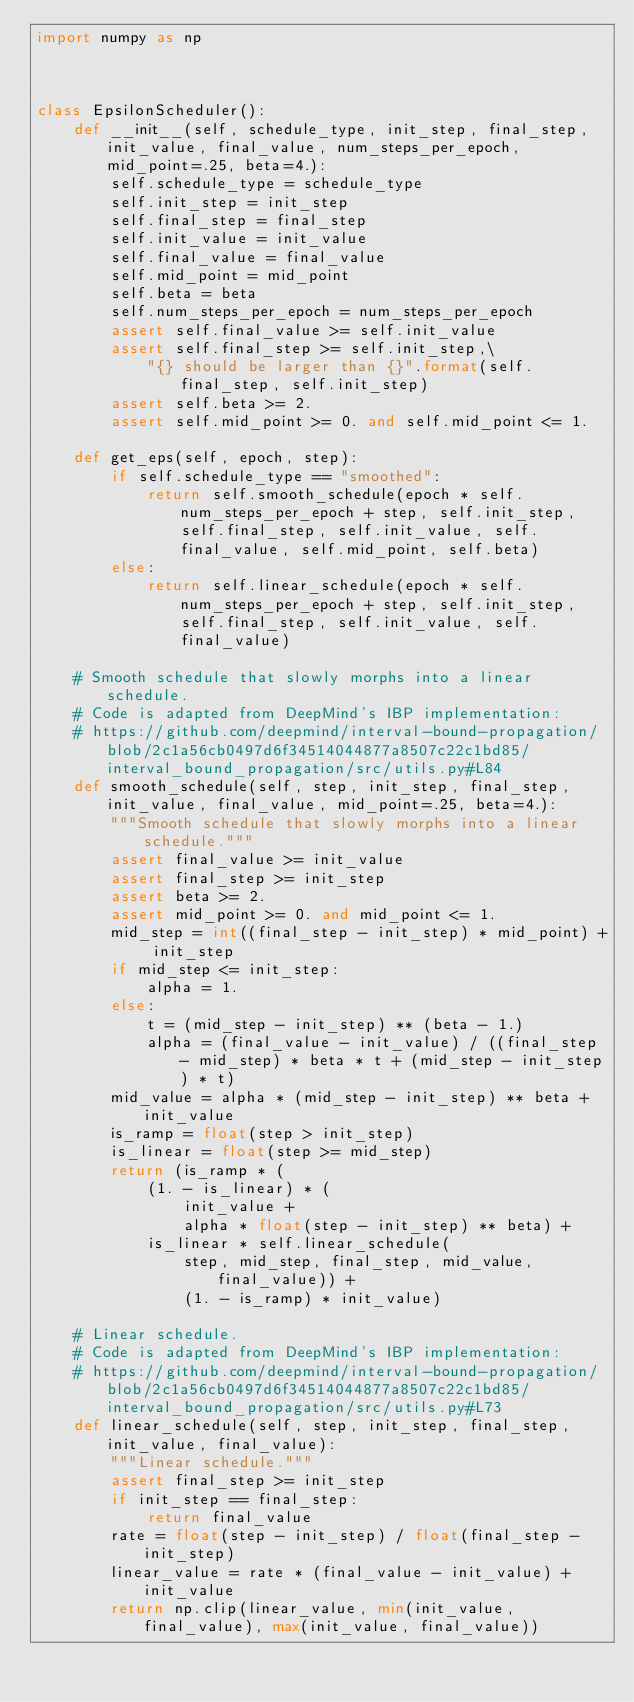<code> <loc_0><loc_0><loc_500><loc_500><_Python_>import numpy as np

 

class EpsilonScheduler():
    def __init__(self, schedule_type, init_step, final_step, init_value, final_value, num_steps_per_epoch, mid_point=.25, beta=4.):
        self.schedule_type = schedule_type
        self.init_step = init_step
        self.final_step = final_step
        self.init_value = init_value
        self.final_value = final_value
        self.mid_point = mid_point
        self.beta = beta
        self.num_steps_per_epoch = num_steps_per_epoch
        assert self.final_value >= self.init_value
        assert self.final_step >= self.init_step,\
            "{} should be larger than {}".format(self.final_step, self.init_step)
        assert self.beta >= 2.
        assert self.mid_point >= 0. and self.mid_point <= 1. 
    
    def get_eps(self, epoch, step):
        if self.schedule_type == "smoothed":
            return self.smooth_schedule(epoch * self.num_steps_per_epoch + step, self.init_step, self.final_step, self.init_value, self.final_value, self.mid_point, self.beta)
        else:
            return self.linear_schedule(epoch * self.num_steps_per_epoch + step, self.init_step, self.final_step, self.init_value, self.final_value)
    
    # Smooth schedule that slowly morphs into a linear schedule.
    # Code is adapted from DeepMind's IBP implementation:
    # https://github.com/deepmind/interval-bound-propagation/blob/2c1a56cb0497d6f34514044877a8507c22c1bd85/interval_bound_propagation/src/utils.py#L84
    def smooth_schedule(self, step, init_step, final_step, init_value, final_value, mid_point=.25, beta=4.):
        """Smooth schedule that slowly morphs into a linear schedule."""
        assert final_value >= init_value
        assert final_step >= init_step
        assert beta >= 2.
        assert mid_point >= 0. and mid_point <= 1.
        mid_step = int((final_step - init_step) * mid_point) + init_step 
        if mid_step <= init_step:
            alpha = 1.
        else:
            t = (mid_step - init_step) ** (beta - 1.)
            alpha = (final_value - init_value) / ((final_step - mid_step) * beta * t + (mid_step - init_step) * t)
        mid_value = alpha * (mid_step - init_step) ** beta + init_value
        is_ramp = float(step > init_step)
        is_linear = float(step >= mid_step)
        return (is_ramp * (
            (1. - is_linear) * (
                init_value +
                alpha * float(step - init_step) ** beta) +
            is_linear * self.linear_schedule(
                step, mid_step, final_step, mid_value, final_value)) +
                (1. - is_ramp) * init_value)
        
    # Linear schedule.
    # Code is adapted from DeepMind's IBP implementation:
    # https://github.com/deepmind/interval-bound-propagation/blob/2c1a56cb0497d6f34514044877a8507c22c1bd85/interval_bound_propagation/src/utils.py#L73 
    def linear_schedule(self, step, init_step, final_step, init_value, final_value):
        """Linear schedule."""
        assert final_step >= init_step
        if init_step == final_step:
            return final_value
        rate = float(step - init_step) / float(final_step - init_step)
        linear_value = rate * (final_value - init_value) + init_value
        return np.clip(linear_value, min(init_value, final_value), max(init_value, final_value))
</code> 